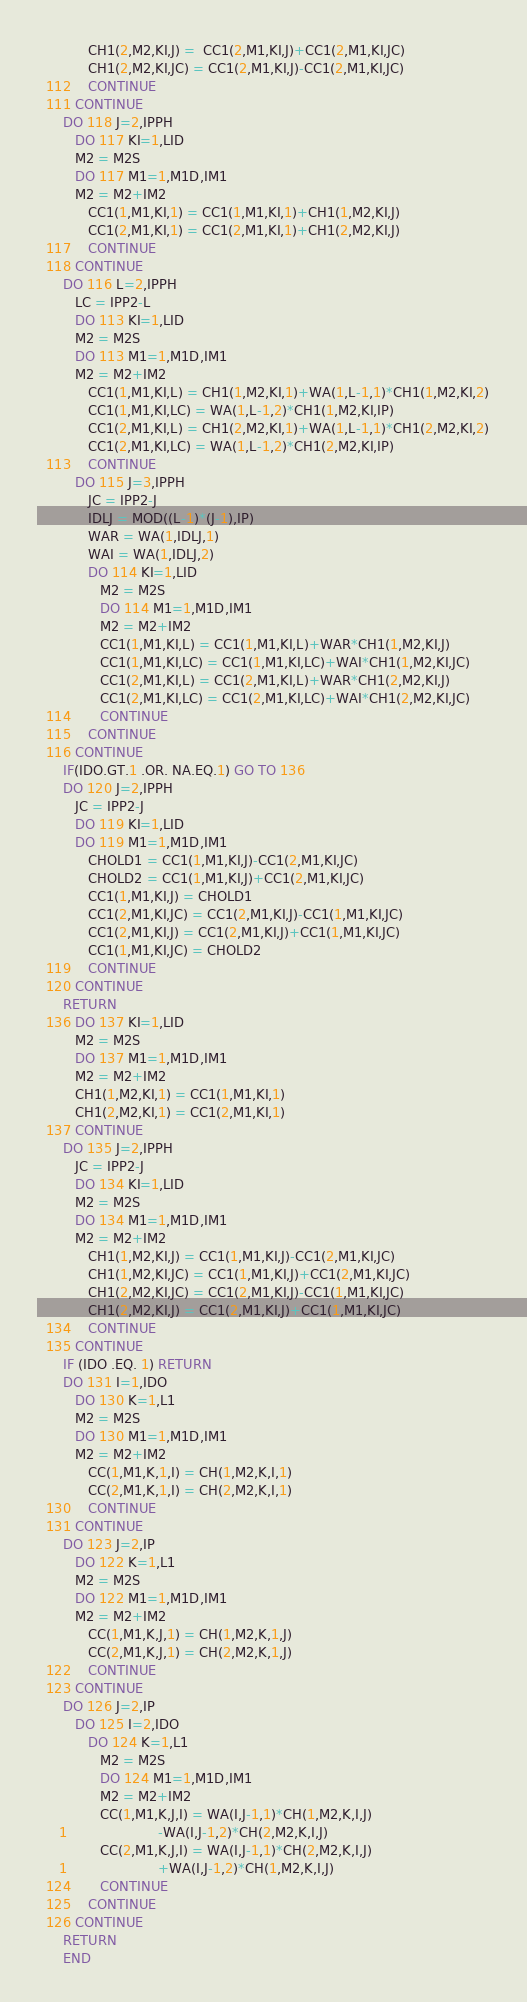Convert code to text. <code><loc_0><loc_0><loc_500><loc_500><_FORTRAN_>            CH1(2,M2,KI,J) =  CC1(2,M1,KI,J)+CC1(2,M1,KI,JC)
            CH1(2,M2,KI,JC) = CC1(2,M1,KI,J)-CC1(2,M1,KI,JC)
  112    CONTINUE
  111 CONTINUE
      DO 118 J=2,IPPH
         DO 117 KI=1,LID
         M2 = M2S
         DO 117 M1=1,M1D,IM1
         M2 = M2+IM2
            CC1(1,M1,KI,1) = CC1(1,M1,KI,1)+CH1(1,M2,KI,J)
            CC1(2,M1,KI,1) = CC1(2,M1,KI,1)+CH1(2,M2,KI,J)
  117    CONTINUE
  118 CONTINUE
      DO 116 L=2,IPPH
         LC = IPP2-L
         DO 113 KI=1,LID
         M2 = M2S
         DO 113 M1=1,M1D,IM1
         M2 = M2+IM2
            CC1(1,M1,KI,L) = CH1(1,M2,KI,1)+WA(1,L-1,1)*CH1(1,M2,KI,2)
            CC1(1,M1,KI,LC) = WA(1,L-1,2)*CH1(1,M2,KI,IP)
            CC1(2,M1,KI,L) = CH1(2,M2,KI,1)+WA(1,L-1,1)*CH1(2,M2,KI,2)
            CC1(2,M1,KI,LC) = WA(1,L-1,2)*CH1(2,M2,KI,IP)
  113    CONTINUE
         DO 115 J=3,IPPH
            JC = IPP2-J
            IDLJ = MOD((L-1)*(J-1),IP)
            WAR = WA(1,IDLJ,1)
            WAI = WA(1,IDLJ,2)
            DO 114 KI=1,LID
               M2 = M2S
               DO 114 M1=1,M1D,IM1
               M2 = M2+IM2
               CC1(1,M1,KI,L) = CC1(1,M1,KI,L)+WAR*CH1(1,M2,KI,J)
               CC1(1,M1,KI,LC) = CC1(1,M1,KI,LC)+WAI*CH1(1,M2,KI,JC)
               CC1(2,M1,KI,L) = CC1(2,M1,KI,L)+WAR*CH1(2,M2,KI,J)
               CC1(2,M1,KI,LC) = CC1(2,M1,KI,LC)+WAI*CH1(2,M2,KI,JC)
  114       CONTINUE
  115    CONTINUE
  116 CONTINUE
      IF(IDO.GT.1 .OR. NA.EQ.1) GO TO 136
      DO 120 J=2,IPPH
         JC = IPP2-J
         DO 119 KI=1,LID
         DO 119 M1=1,M1D,IM1
            CHOLD1 = CC1(1,M1,KI,J)-CC1(2,M1,KI,JC)
            CHOLD2 = CC1(1,M1,KI,J)+CC1(2,M1,KI,JC)
            CC1(1,M1,KI,J) = CHOLD1
            CC1(2,M1,KI,JC) = CC1(2,M1,KI,J)-CC1(1,M1,KI,JC)
            CC1(2,M1,KI,J) = CC1(2,M1,KI,J)+CC1(1,M1,KI,JC)
            CC1(1,M1,KI,JC) = CHOLD2
  119    CONTINUE
  120 CONTINUE
      RETURN
  136 DO 137 KI=1,LID
         M2 = M2S
         DO 137 M1=1,M1D,IM1
         M2 = M2+IM2
         CH1(1,M2,KI,1) = CC1(1,M1,KI,1)
         CH1(2,M2,KI,1) = CC1(2,M1,KI,1)
  137 CONTINUE
      DO 135 J=2,IPPH
         JC = IPP2-J
         DO 134 KI=1,LID
         M2 = M2S
         DO 134 M1=1,M1D,IM1
         M2 = M2+IM2
            CH1(1,M2,KI,J) = CC1(1,M1,KI,J)-CC1(2,M1,KI,JC)
            CH1(1,M2,KI,JC) = CC1(1,M1,KI,J)+CC1(2,M1,KI,JC)
            CH1(2,M2,KI,JC) = CC1(2,M1,KI,J)-CC1(1,M1,KI,JC)
            CH1(2,M2,KI,J) = CC1(2,M1,KI,J)+CC1(1,M1,KI,JC)
  134    CONTINUE
  135 CONTINUE
      IF (IDO .EQ. 1) RETURN
      DO 131 I=1,IDO
         DO 130 K=1,L1
         M2 = M2S
         DO 130 M1=1,M1D,IM1
         M2 = M2+IM2
            CC(1,M1,K,1,I) = CH(1,M2,K,I,1)
            CC(2,M1,K,1,I) = CH(2,M2,K,I,1)
  130    CONTINUE
  131 CONTINUE
      DO 123 J=2,IP
         DO 122 K=1,L1
         M2 = M2S
         DO 122 M1=1,M1D,IM1
         M2 = M2+IM2
            CC(1,M1,K,J,1) = CH(1,M2,K,1,J)
            CC(2,M1,K,J,1) = CH(2,M2,K,1,J)
  122    CONTINUE
  123 CONTINUE
      DO 126 J=2,IP
         DO 125 I=2,IDO
            DO 124 K=1,L1
               M2 = M2S
               DO 124 M1=1,M1D,IM1
               M2 = M2+IM2
               CC(1,M1,K,J,I) = WA(I,J-1,1)*CH(1,M2,K,I,J)
     1                      -WA(I,J-1,2)*CH(2,M2,K,I,J)
               CC(2,M1,K,J,I) = WA(I,J-1,1)*CH(2,M2,K,I,J)
     1                      +WA(I,J-1,2)*CH(1,M2,K,I,J)
  124       CONTINUE
  125    CONTINUE
  126 CONTINUE
      RETURN
      END
</code> 